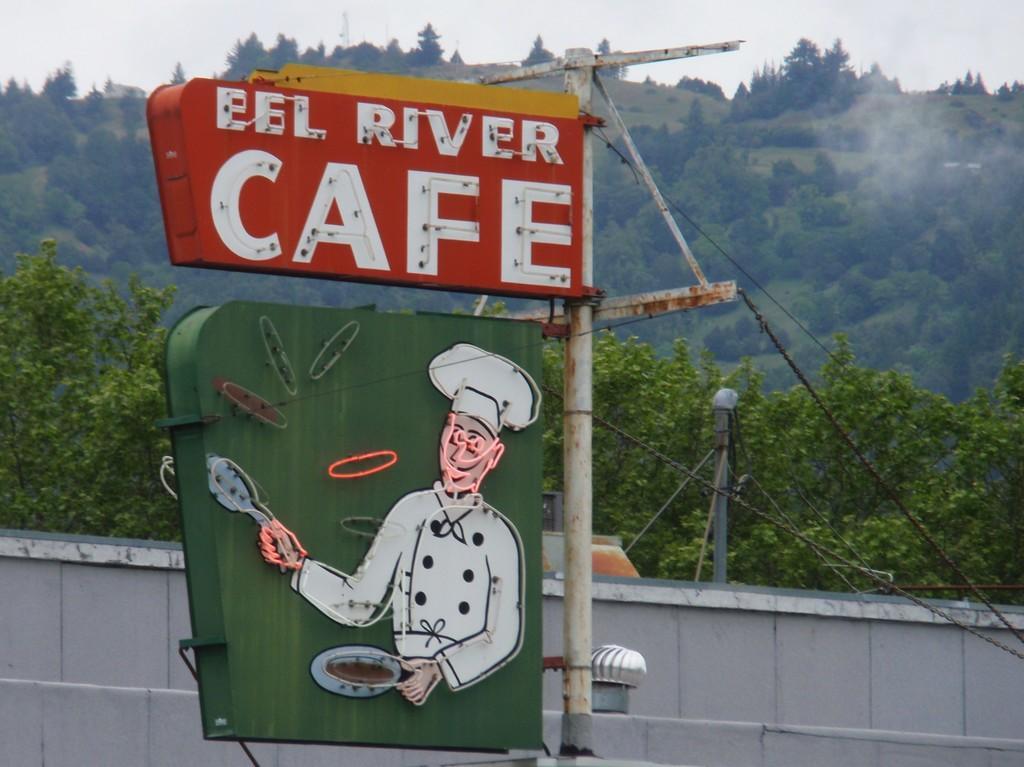Please provide a concise description of this image. In this picture i can see the sign board which is attached on the pole. In the back there is a shed. In the background i can see mountain and many trees. At the top i can see the sky and clouds. 